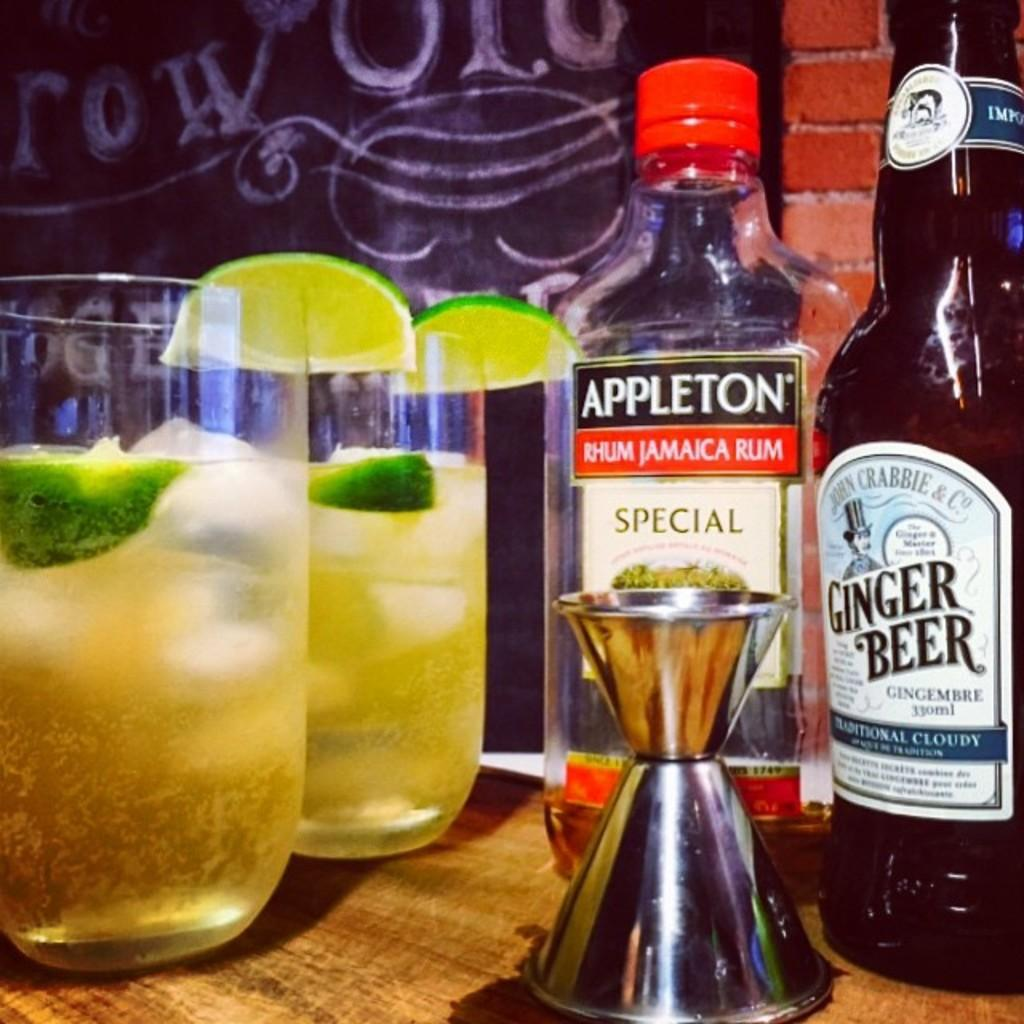<image>
Offer a succinct explanation of the picture presented. Ginger Beer next to a bottle of Appleton rum. 